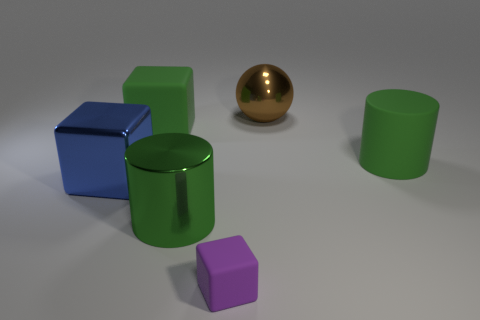Subtract all rubber cubes. How many cubes are left? 1 Add 4 green matte objects. How many objects exist? 10 Subtract all spheres. How many objects are left? 5 Subtract all blue metal things. Subtract all big brown things. How many objects are left? 4 Add 4 brown metal spheres. How many brown metal spheres are left? 5 Add 4 purple matte cubes. How many purple matte cubes exist? 5 Subtract 1 brown spheres. How many objects are left? 5 